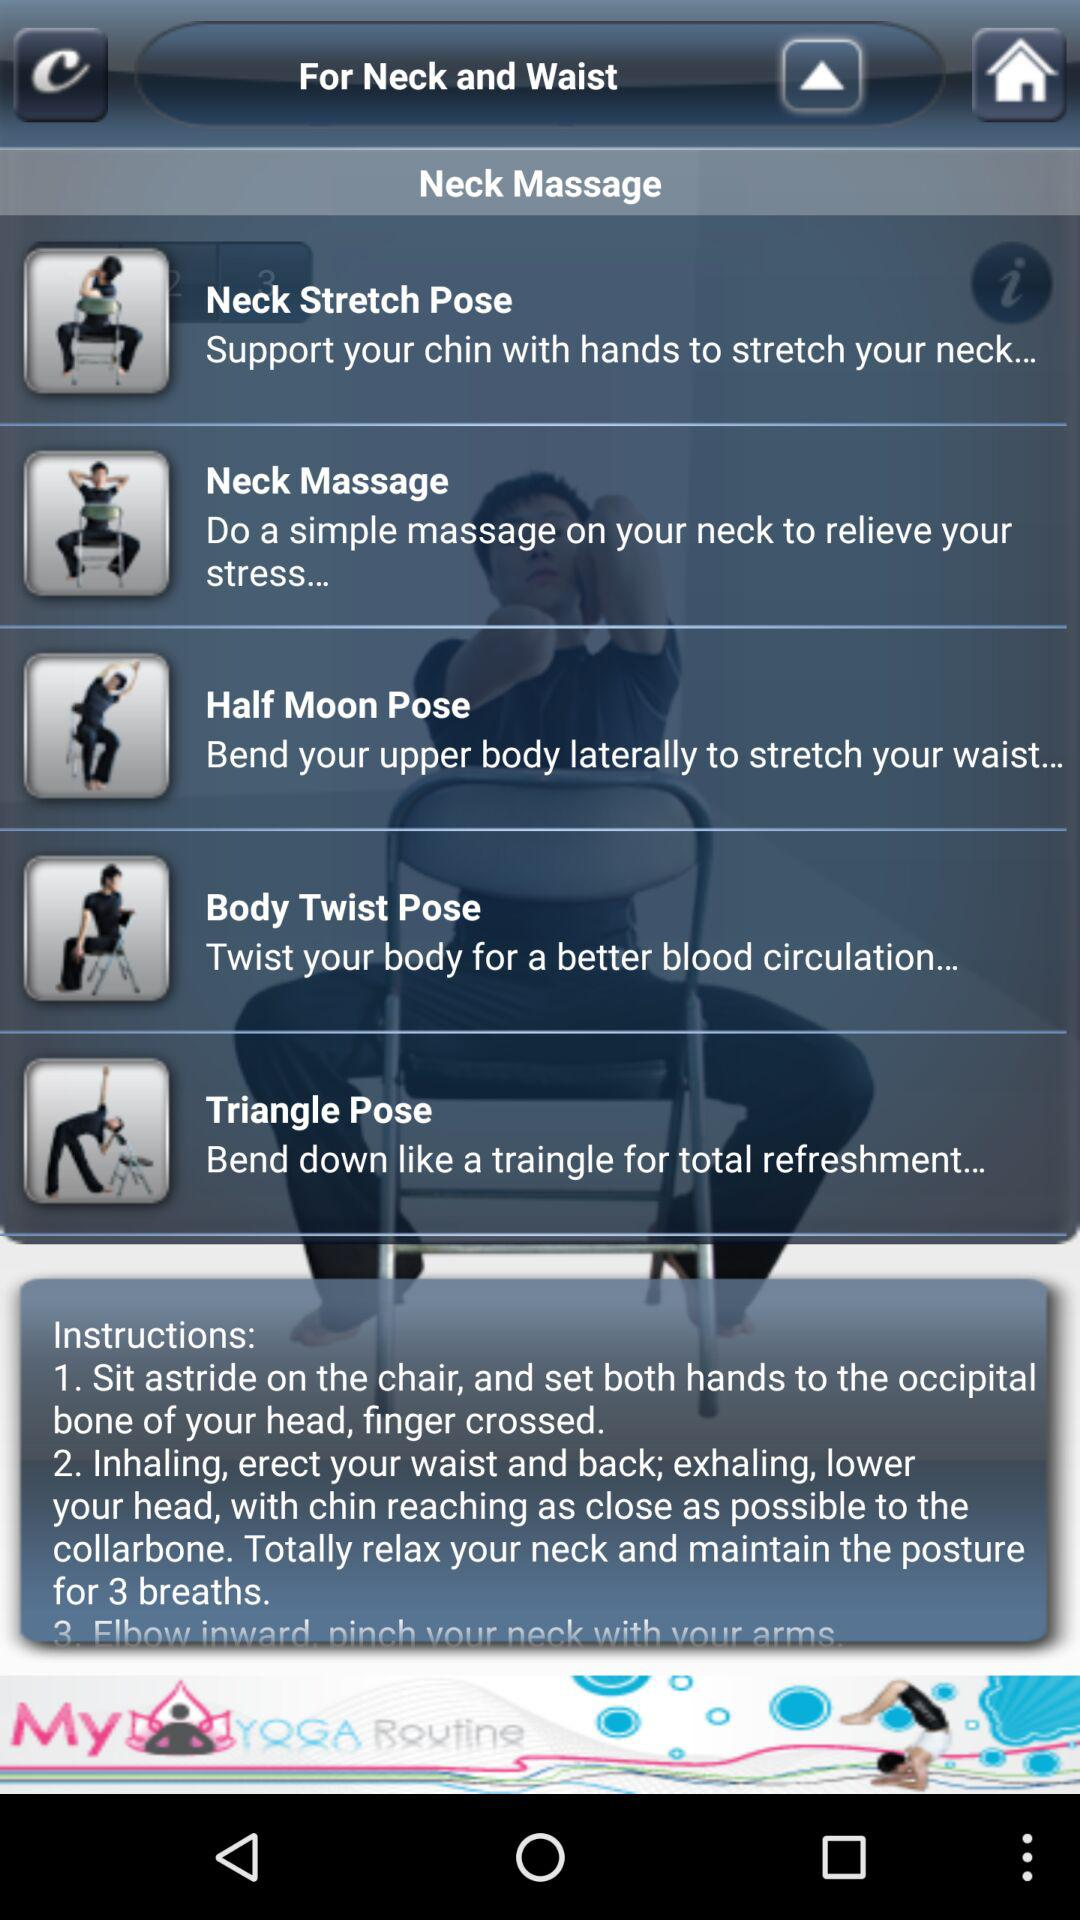What is the description of the "Neck Stretch Pose"? The description of the "Neck Stretch Pose" is "Support your chin with hands to stretch your neck...". 